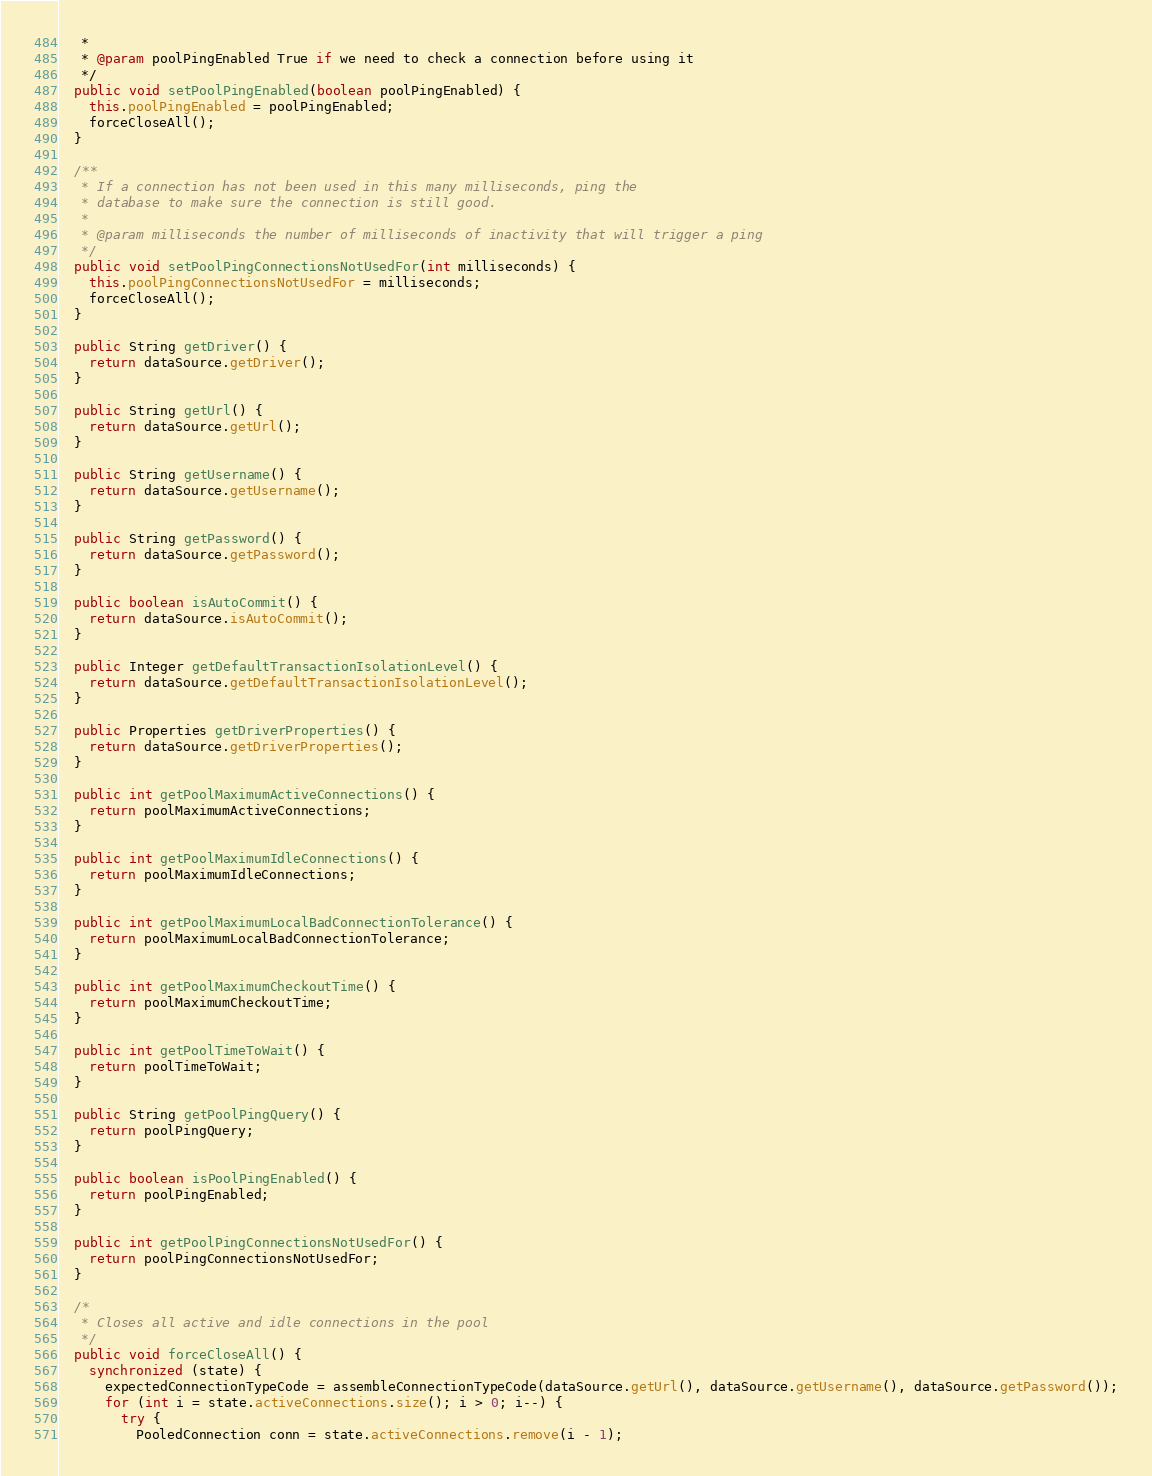<code> <loc_0><loc_0><loc_500><loc_500><_Java_>   *
   * @param poolPingEnabled True if we need to check a connection before using it
   */
  public void setPoolPingEnabled(boolean poolPingEnabled) {
    this.poolPingEnabled = poolPingEnabled;
    forceCloseAll();
  }

  /**
   * If a connection has not been used in this many milliseconds, ping the
   * database to make sure the connection is still good.
   *
   * @param milliseconds the number of milliseconds of inactivity that will trigger a ping
   */
  public void setPoolPingConnectionsNotUsedFor(int milliseconds) {
    this.poolPingConnectionsNotUsedFor = milliseconds;
    forceCloseAll();
  }

  public String getDriver() {
    return dataSource.getDriver();
  }

  public String getUrl() {
    return dataSource.getUrl();
  }

  public String getUsername() {
    return dataSource.getUsername();
  }

  public String getPassword() {
    return dataSource.getPassword();
  }

  public boolean isAutoCommit() {
    return dataSource.isAutoCommit();
  }

  public Integer getDefaultTransactionIsolationLevel() {
    return dataSource.getDefaultTransactionIsolationLevel();
  }

  public Properties getDriverProperties() {
    return dataSource.getDriverProperties();
  }

  public int getPoolMaximumActiveConnections() {
    return poolMaximumActiveConnections;
  }

  public int getPoolMaximumIdleConnections() {
    return poolMaximumIdleConnections;
  }

  public int getPoolMaximumLocalBadConnectionTolerance() {
    return poolMaximumLocalBadConnectionTolerance;
  }

  public int getPoolMaximumCheckoutTime() {
    return poolMaximumCheckoutTime;
  }

  public int getPoolTimeToWait() {
    return poolTimeToWait;
  }

  public String getPoolPingQuery() {
    return poolPingQuery;
  }

  public boolean isPoolPingEnabled() {
    return poolPingEnabled;
  }

  public int getPoolPingConnectionsNotUsedFor() {
    return poolPingConnectionsNotUsedFor;
  }

  /*
   * Closes all active and idle connections in the pool
   */
  public void forceCloseAll() {
    synchronized (state) {
      expectedConnectionTypeCode = assembleConnectionTypeCode(dataSource.getUrl(), dataSource.getUsername(), dataSource.getPassword());
      for (int i = state.activeConnections.size(); i > 0; i--) {
        try {
          PooledConnection conn = state.activeConnections.remove(i - 1);</code> 